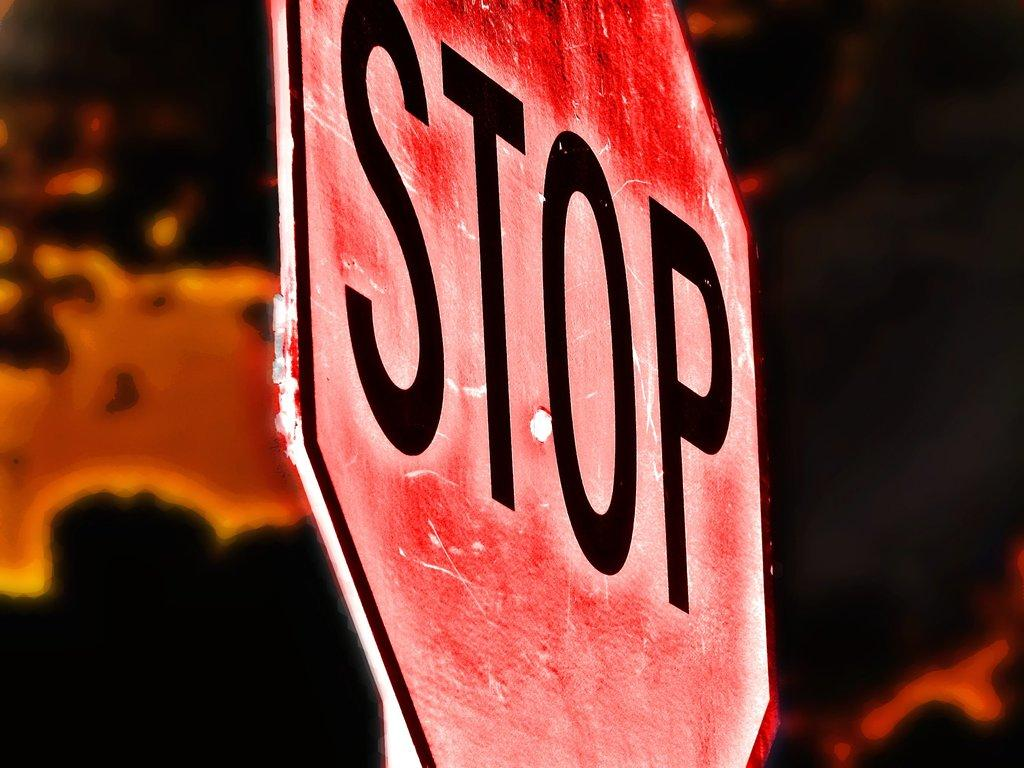<image>
Describe the image concisely. Red sign that has the word STOP in black. 